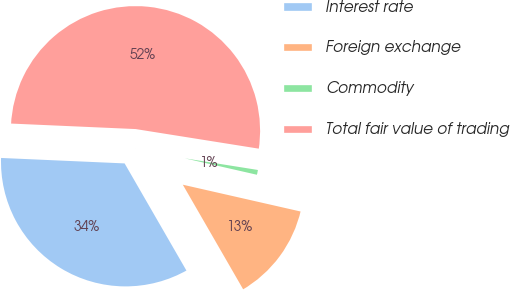<chart> <loc_0><loc_0><loc_500><loc_500><pie_chart><fcel>Interest rate<fcel>Foreign exchange<fcel>Commodity<fcel>Total fair value of trading<nl><fcel>34.03%<fcel>13.11%<fcel>1.05%<fcel>51.81%<nl></chart> 